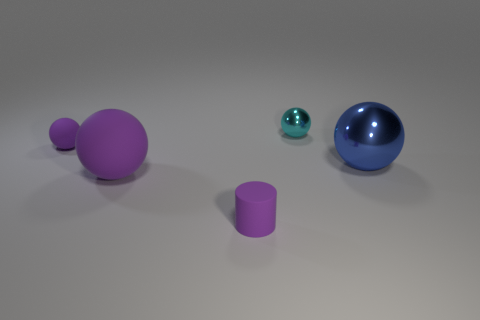How many objects are either large green metallic blocks or small purple rubber things that are to the left of the big purple ball?
Give a very brief answer. 1. What is the size of the matte sphere in front of the small rubber ball?
Your answer should be compact. Large. Is the number of tiny shiny spheres that are to the left of the tiny metal sphere less than the number of small purple rubber objects that are left of the big purple matte ball?
Your response must be concise. Yes. What is the material of the tiny thing that is right of the small purple ball and behind the large metal object?
Offer a very short reply. Metal. What is the shape of the small rubber thing to the right of the tiny purple sphere behind the large purple rubber ball?
Ensure brevity in your answer.  Cylinder. Is the small rubber cylinder the same color as the big rubber thing?
Make the answer very short. Yes. Are there any purple matte objects to the left of the small purple sphere?
Your response must be concise. No. The cylinder has what size?
Make the answer very short. Small. The blue object that is the same shape as the small cyan metallic thing is what size?
Your answer should be compact. Large. How many cyan objects are right of the metallic thing on the right side of the tiny cyan shiny thing?
Keep it short and to the point. 0. 